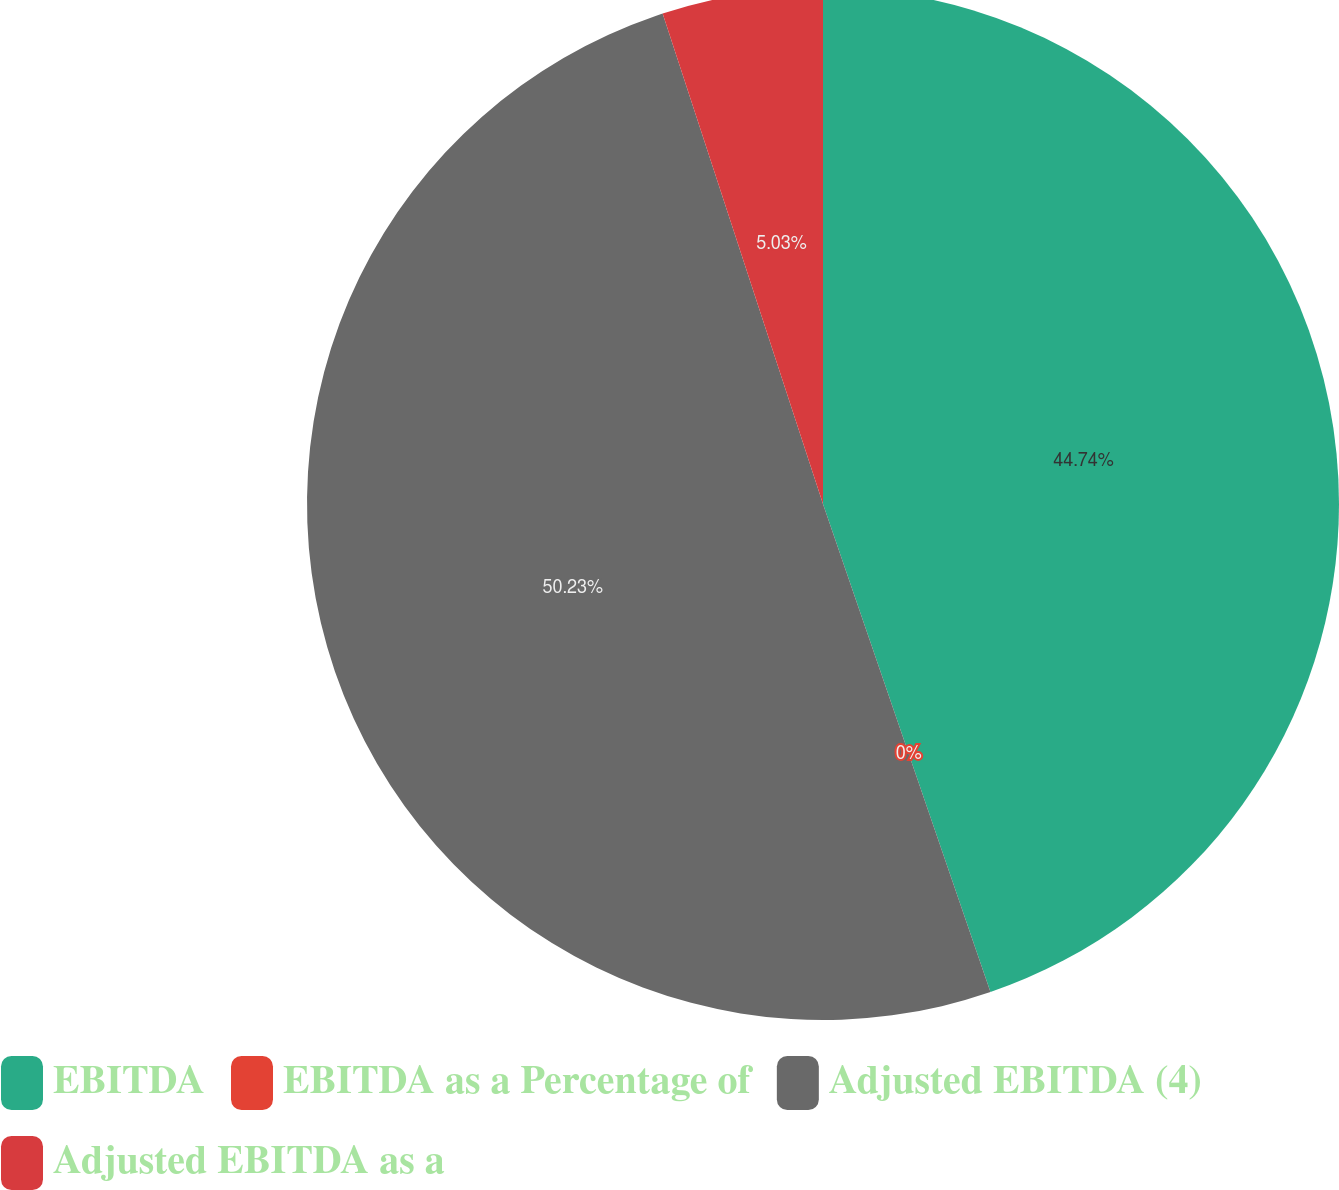Convert chart to OTSL. <chart><loc_0><loc_0><loc_500><loc_500><pie_chart><fcel>EBITDA<fcel>EBITDA as a Percentage of<fcel>Adjusted EBITDA (4)<fcel>Adjusted EBITDA as a<nl><fcel>44.74%<fcel>0.0%<fcel>50.23%<fcel>5.03%<nl></chart> 